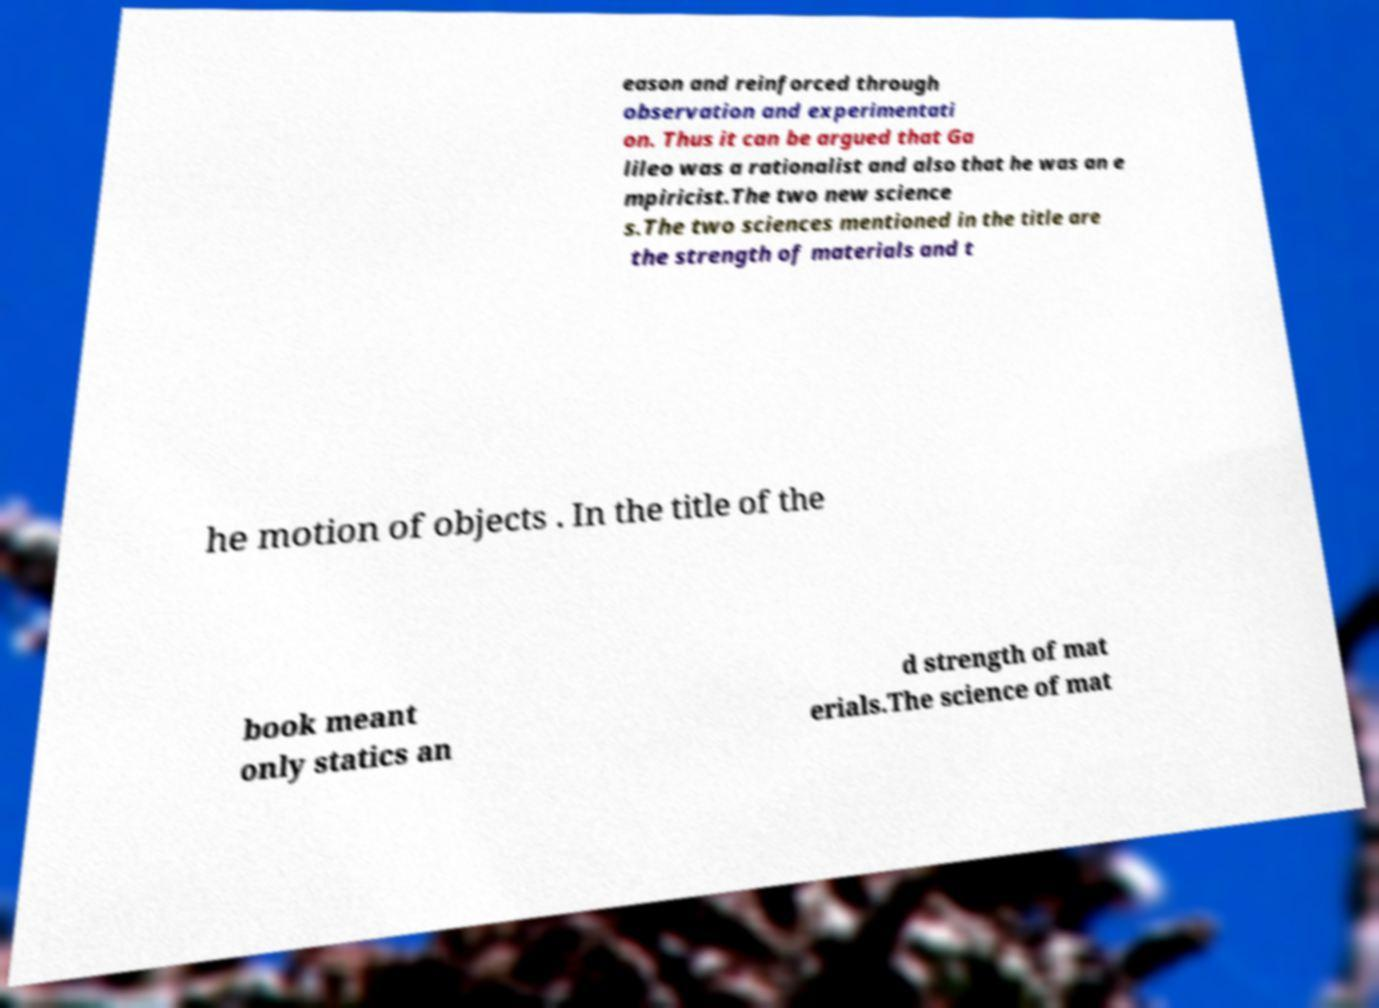Could you assist in decoding the text presented in this image and type it out clearly? eason and reinforced through observation and experimentati on. Thus it can be argued that Ga lileo was a rationalist and also that he was an e mpiricist.The two new science s.The two sciences mentioned in the title are the strength of materials and t he motion of objects . In the title of the book meant only statics an d strength of mat erials.The science of mat 